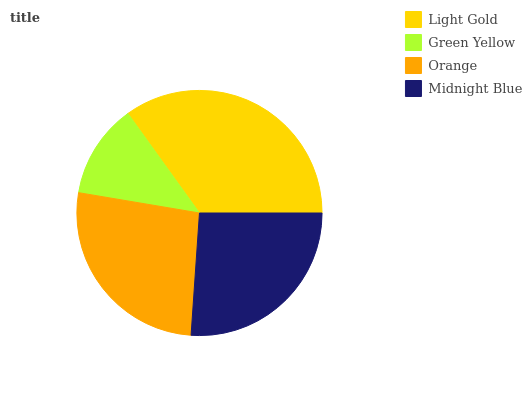Is Green Yellow the minimum?
Answer yes or no. Yes. Is Light Gold the maximum?
Answer yes or no. Yes. Is Orange the minimum?
Answer yes or no. No. Is Orange the maximum?
Answer yes or no. No. Is Orange greater than Green Yellow?
Answer yes or no. Yes. Is Green Yellow less than Orange?
Answer yes or no. Yes. Is Green Yellow greater than Orange?
Answer yes or no. No. Is Orange less than Green Yellow?
Answer yes or no. No. Is Orange the high median?
Answer yes or no. Yes. Is Midnight Blue the low median?
Answer yes or no. Yes. Is Light Gold the high median?
Answer yes or no. No. Is Light Gold the low median?
Answer yes or no. No. 